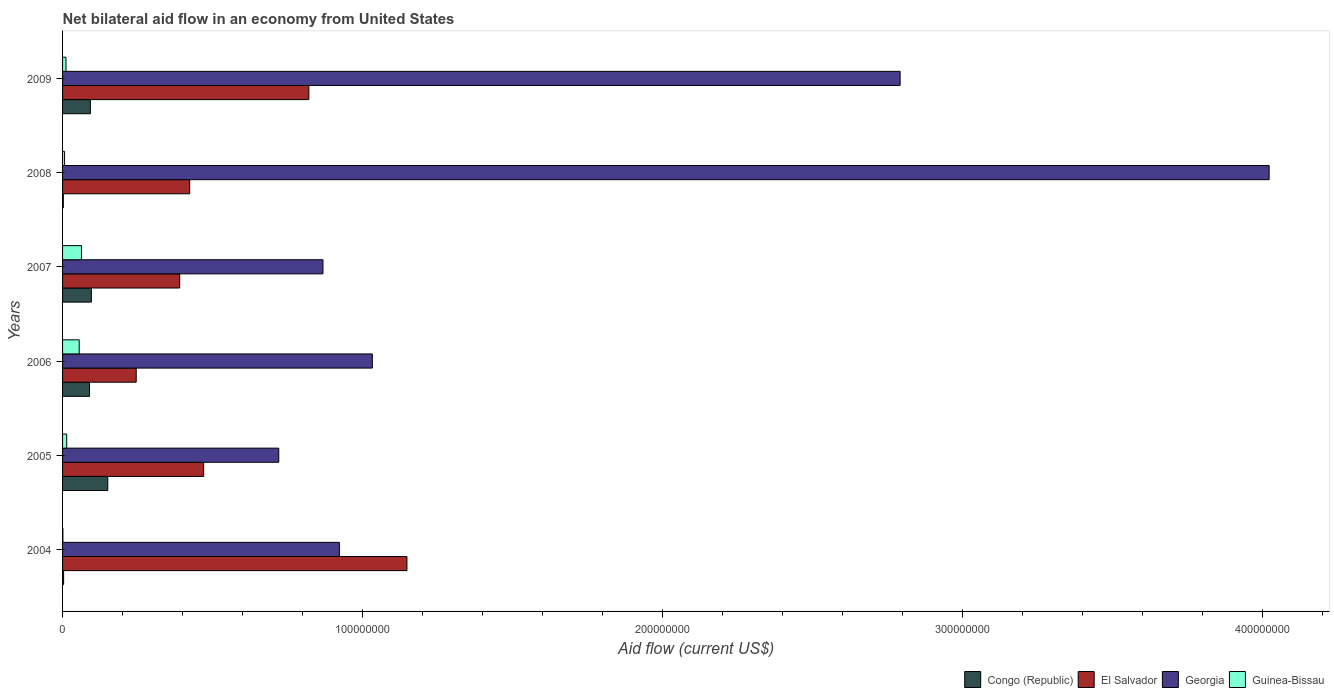How many groups of bars are there?
Ensure brevity in your answer.  6. Are the number of bars per tick equal to the number of legend labels?
Keep it short and to the point. Yes. Are the number of bars on each tick of the Y-axis equal?
Your response must be concise. Yes. How many bars are there on the 6th tick from the top?
Offer a very short reply. 4. How many bars are there on the 3rd tick from the bottom?
Give a very brief answer. 4. What is the net bilateral aid flow in El Salvador in 2005?
Offer a terse response. 4.70e+07. Across all years, what is the maximum net bilateral aid flow in Georgia?
Offer a very short reply. 4.02e+08. Across all years, what is the minimum net bilateral aid flow in Georgia?
Provide a short and direct response. 7.20e+07. In which year was the net bilateral aid flow in El Salvador maximum?
Make the answer very short. 2004. In which year was the net bilateral aid flow in Congo (Republic) minimum?
Offer a very short reply. 2008. What is the total net bilateral aid flow in Guinea-Bissau in the graph?
Offer a very short reply. 1.51e+07. What is the difference between the net bilateral aid flow in Guinea-Bissau in 2004 and that in 2009?
Provide a short and direct response. -1.03e+06. What is the difference between the net bilateral aid flow in Guinea-Bissau in 2006 and the net bilateral aid flow in Congo (Republic) in 2007?
Ensure brevity in your answer.  -4.06e+06. What is the average net bilateral aid flow in Congo (Republic) per year?
Offer a terse response. 7.26e+06. In the year 2009, what is the difference between the net bilateral aid flow in Guinea-Bissau and net bilateral aid flow in Congo (Republic)?
Give a very brief answer. -8.13e+06. In how many years, is the net bilateral aid flow in El Salvador greater than 80000000 US$?
Provide a succinct answer. 2. What is the ratio of the net bilateral aid flow in Georgia in 2005 to that in 2006?
Offer a very short reply. 0.7. What is the difference between the highest and the second highest net bilateral aid flow in Congo (Republic)?
Provide a short and direct response. 5.47e+06. What is the difference between the highest and the lowest net bilateral aid flow in Congo (Republic)?
Your answer should be very brief. 1.48e+07. In how many years, is the net bilateral aid flow in Congo (Republic) greater than the average net bilateral aid flow in Congo (Republic) taken over all years?
Offer a terse response. 4. What does the 1st bar from the top in 2006 represents?
Give a very brief answer. Guinea-Bissau. What does the 2nd bar from the bottom in 2006 represents?
Make the answer very short. El Salvador. Is it the case that in every year, the sum of the net bilateral aid flow in El Salvador and net bilateral aid flow in Georgia is greater than the net bilateral aid flow in Congo (Republic)?
Give a very brief answer. Yes. How many bars are there?
Offer a very short reply. 24. What is the difference between two consecutive major ticks on the X-axis?
Offer a very short reply. 1.00e+08. Where does the legend appear in the graph?
Your response must be concise. Bottom right. What is the title of the graph?
Offer a terse response. Net bilateral aid flow in an economy from United States. What is the Aid flow (current US$) of Congo (Republic) in 2004?
Provide a succinct answer. 3.50e+05. What is the Aid flow (current US$) in El Salvador in 2004?
Your answer should be compact. 1.15e+08. What is the Aid flow (current US$) of Georgia in 2004?
Make the answer very short. 9.23e+07. What is the Aid flow (current US$) of Guinea-Bissau in 2004?
Your answer should be very brief. 1.10e+05. What is the Aid flow (current US$) of Congo (Republic) in 2005?
Your response must be concise. 1.51e+07. What is the Aid flow (current US$) in El Salvador in 2005?
Offer a terse response. 4.70e+07. What is the Aid flow (current US$) of Georgia in 2005?
Offer a terse response. 7.20e+07. What is the Aid flow (current US$) in Guinea-Bissau in 2005?
Your answer should be compact. 1.38e+06. What is the Aid flow (current US$) in Congo (Republic) in 2006?
Offer a very short reply. 8.98e+06. What is the Aid flow (current US$) in El Salvador in 2006?
Your answer should be very brief. 2.45e+07. What is the Aid flow (current US$) of Georgia in 2006?
Ensure brevity in your answer.  1.03e+08. What is the Aid flow (current US$) in Guinea-Bissau in 2006?
Provide a succinct answer. 5.54e+06. What is the Aid flow (current US$) of Congo (Republic) in 2007?
Provide a short and direct response. 9.60e+06. What is the Aid flow (current US$) in El Salvador in 2007?
Your answer should be very brief. 3.90e+07. What is the Aid flow (current US$) of Georgia in 2007?
Your response must be concise. 8.68e+07. What is the Aid flow (current US$) of Guinea-Bissau in 2007?
Provide a succinct answer. 6.30e+06. What is the Aid flow (current US$) in El Salvador in 2008?
Provide a succinct answer. 4.24e+07. What is the Aid flow (current US$) in Georgia in 2008?
Offer a very short reply. 4.02e+08. What is the Aid flow (current US$) of Guinea-Bissau in 2008?
Provide a succinct answer. 6.70e+05. What is the Aid flow (current US$) in Congo (Republic) in 2009?
Offer a terse response. 9.27e+06. What is the Aid flow (current US$) in El Salvador in 2009?
Offer a very short reply. 8.21e+07. What is the Aid flow (current US$) of Georgia in 2009?
Provide a succinct answer. 2.79e+08. What is the Aid flow (current US$) of Guinea-Bissau in 2009?
Your response must be concise. 1.14e+06. Across all years, what is the maximum Aid flow (current US$) of Congo (Republic)?
Ensure brevity in your answer.  1.51e+07. Across all years, what is the maximum Aid flow (current US$) in El Salvador?
Keep it short and to the point. 1.15e+08. Across all years, what is the maximum Aid flow (current US$) in Georgia?
Provide a short and direct response. 4.02e+08. Across all years, what is the maximum Aid flow (current US$) of Guinea-Bissau?
Keep it short and to the point. 6.30e+06. Across all years, what is the minimum Aid flow (current US$) of El Salvador?
Provide a short and direct response. 2.45e+07. Across all years, what is the minimum Aid flow (current US$) of Georgia?
Make the answer very short. 7.20e+07. Across all years, what is the minimum Aid flow (current US$) in Guinea-Bissau?
Provide a succinct answer. 1.10e+05. What is the total Aid flow (current US$) of Congo (Republic) in the graph?
Make the answer very short. 4.35e+07. What is the total Aid flow (current US$) of El Salvador in the graph?
Provide a short and direct response. 3.50e+08. What is the total Aid flow (current US$) in Georgia in the graph?
Your answer should be compact. 1.04e+09. What is the total Aid flow (current US$) in Guinea-Bissau in the graph?
Keep it short and to the point. 1.51e+07. What is the difference between the Aid flow (current US$) in Congo (Republic) in 2004 and that in 2005?
Make the answer very short. -1.47e+07. What is the difference between the Aid flow (current US$) in El Salvador in 2004 and that in 2005?
Provide a succinct answer. 6.77e+07. What is the difference between the Aid flow (current US$) of Georgia in 2004 and that in 2005?
Your answer should be very brief. 2.02e+07. What is the difference between the Aid flow (current US$) in Guinea-Bissau in 2004 and that in 2005?
Ensure brevity in your answer.  -1.27e+06. What is the difference between the Aid flow (current US$) of Congo (Republic) in 2004 and that in 2006?
Your answer should be very brief. -8.63e+06. What is the difference between the Aid flow (current US$) in El Salvador in 2004 and that in 2006?
Ensure brevity in your answer.  9.02e+07. What is the difference between the Aid flow (current US$) of Georgia in 2004 and that in 2006?
Ensure brevity in your answer.  -1.10e+07. What is the difference between the Aid flow (current US$) of Guinea-Bissau in 2004 and that in 2006?
Give a very brief answer. -5.43e+06. What is the difference between the Aid flow (current US$) of Congo (Republic) in 2004 and that in 2007?
Give a very brief answer. -9.25e+06. What is the difference between the Aid flow (current US$) of El Salvador in 2004 and that in 2007?
Your response must be concise. 7.57e+07. What is the difference between the Aid flow (current US$) of Georgia in 2004 and that in 2007?
Make the answer very short. 5.48e+06. What is the difference between the Aid flow (current US$) of Guinea-Bissau in 2004 and that in 2007?
Give a very brief answer. -6.19e+06. What is the difference between the Aid flow (current US$) of Congo (Republic) in 2004 and that in 2008?
Ensure brevity in your answer.  9.00e+04. What is the difference between the Aid flow (current US$) of El Salvador in 2004 and that in 2008?
Make the answer very short. 7.24e+07. What is the difference between the Aid flow (current US$) in Georgia in 2004 and that in 2008?
Offer a very short reply. -3.10e+08. What is the difference between the Aid flow (current US$) in Guinea-Bissau in 2004 and that in 2008?
Provide a short and direct response. -5.60e+05. What is the difference between the Aid flow (current US$) in Congo (Republic) in 2004 and that in 2009?
Provide a short and direct response. -8.92e+06. What is the difference between the Aid flow (current US$) in El Salvador in 2004 and that in 2009?
Your answer should be very brief. 3.27e+07. What is the difference between the Aid flow (current US$) of Georgia in 2004 and that in 2009?
Make the answer very short. -1.87e+08. What is the difference between the Aid flow (current US$) in Guinea-Bissau in 2004 and that in 2009?
Make the answer very short. -1.03e+06. What is the difference between the Aid flow (current US$) in Congo (Republic) in 2005 and that in 2006?
Keep it short and to the point. 6.09e+06. What is the difference between the Aid flow (current US$) in El Salvador in 2005 and that in 2006?
Keep it short and to the point. 2.25e+07. What is the difference between the Aid flow (current US$) in Georgia in 2005 and that in 2006?
Make the answer very short. -3.12e+07. What is the difference between the Aid flow (current US$) in Guinea-Bissau in 2005 and that in 2006?
Offer a very short reply. -4.16e+06. What is the difference between the Aid flow (current US$) in Congo (Republic) in 2005 and that in 2007?
Offer a very short reply. 5.47e+06. What is the difference between the Aid flow (current US$) of El Salvador in 2005 and that in 2007?
Your response must be concise. 7.98e+06. What is the difference between the Aid flow (current US$) of Georgia in 2005 and that in 2007?
Your response must be concise. -1.47e+07. What is the difference between the Aid flow (current US$) of Guinea-Bissau in 2005 and that in 2007?
Provide a short and direct response. -4.92e+06. What is the difference between the Aid flow (current US$) in Congo (Republic) in 2005 and that in 2008?
Your answer should be compact. 1.48e+07. What is the difference between the Aid flow (current US$) of El Salvador in 2005 and that in 2008?
Keep it short and to the point. 4.65e+06. What is the difference between the Aid flow (current US$) of Georgia in 2005 and that in 2008?
Your answer should be compact. -3.30e+08. What is the difference between the Aid flow (current US$) in Guinea-Bissau in 2005 and that in 2008?
Give a very brief answer. 7.10e+05. What is the difference between the Aid flow (current US$) of Congo (Republic) in 2005 and that in 2009?
Make the answer very short. 5.80e+06. What is the difference between the Aid flow (current US$) of El Salvador in 2005 and that in 2009?
Provide a short and direct response. -3.51e+07. What is the difference between the Aid flow (current US$) in Georgia in 2005 and that in 2009?
Ensure brevity in your answer.  -2.07e+08. What is the difference between the Aid flow (current US$) of Guinea-Bissau in 2005 and that in 2009?
Your answer should be compact. 2.40e+05. What is the difference between the Aid flow (current US$) of Congo (Republic) in 2006 and that in 2007?
Make the answer very short. -6.20e+05. What is the difference between the Aid flow (current US$) in El Salvador in 2006 and that in 2007?
Provide a succinct answer. -1.45e+07. What is the difference between the Aid flow (current US$) in Georgia in 2006 and that in 2007?
Give a very brief answer. 1.65e+07. What is the difference between the Aid flow (current US$) of Guinea-Bissau in 2006 and that in 2007?
Provide a short and direct response. -7.60e+05. What is the difference between the Aid flow (current US$) of Congo (Republic) in 2006 and that in 2008?
Make the answer very short. 8.72e+06. What is the difference between the Aid flow (current US$) in El Salvador in 2006 and that in 2008?
Provide a short and direct response. -1.78e+07. What is the difference between the Aid flow (current US$) of Georgia in 2006 and that in 2008?
Give a very brief answer. -2.99e+08. What is the difference between the Aid flow (current US$) of Guinea-Bissau in 2006 and that in 2008?
Offer a very short reply. 4.87e+06. What is the difference between the Aid flow (current US$) of El Salvador in 2006 and that in 2009?
Offer a terse response. -5.75e+07. What is the difference between the Aid flow (current US$) of Georgia in 2006 and that in 2009?
Your answer should be compact. -1.76e+08. What is the difference between the Aid flow (current US$) of Guinea-Bissau in 2006 and that in 2009?
Give a very brief answer. 4.40e+06. What is the difference between the Aid flow (current US$) in Congo (Republic) in 2007 and that in 2008?
Keep it short and to the point. 9.34e+06. What is the difference between the Aid flow (current US$) of El Salvador in 2007 and that in 2008?
Offer a very short reply. -3.33e+06. What is the difference between the Aid flow (current US$) of Georgia in 2007 and that in 2008?
Offer a very short reply. -3.15e+08. What is the difference between the Aid flow (current US$) of Guinea-Bissau in 2007 and that in 2008?
Provide a succinct answer. 5.63e+06. What is the difference between the Aid flow (current US$) of El Salvador in 2007 and that in 2009?
Ensure brevity in your answer.  -4.30e+07. What is the difference between the Aid flow (current US$) in Georgia in 2007 and that in 2009?
Make the answer very short. -1.92e+08. What is the difference between the Aid flow (current US$) of Guinea-Bissau in 2007 and that in 2009?
Provide a succinct answer. 5.16e+06. What is the difference between the Aid flow (current US$) of Congo (Republic) in 2008 and that in 2009?
Your answer should be very brief. -9.01e+06. What is the difference between the Aid flow (current US$) in El Salvador in 2008 and that in 2009?
Ensure brevity in your answer.  -3.97e+07. What is the difference between the Aid flow (current US$) in Georgia in 2008 and that in 2009?
Provide a succinct answer. 1.23e+08. What is the difference between the Aid flow (current US$) in Guinea-Bissau in 2008 and that in 2009?
Your response must be concise. -4.70e+05. What is the difference between the Aid flow (current US$) in Congo (Republic) in 2004 and the Aid flow (current US$) in El Salvador in 2005?
Your answer should be very brief. -4.67e+07. What is the difference between the Aid flow (current US$) in Congo (Republic) in 2004 and the Aid flow (current US$) in Georgia in 2005?
Offer a terse response. -7.17e+07. What is the difference between the Aid flow (current US$) in Congo (Republic) in 2004 and the Aid flow (current US$) in Guinea-Bissau in 2005?
Provide a succinct answer. -1.03e+06. What is the difference between the Aid flow (current US$) in El Salvador in 2004 and the Aid flow (current US$) in Georgia in 2005?
Your response must be concise. 4.27e+07. What is the difference between the Aid flow (current US$) in El Salvador in 2004 and the Aid flow (current US$) in Guinea-Bissau in 2005?
Your response must be concise. 1.13e+08. What is the difference between the Aid flow (current US$) in Georgia in 2004 and the Aid flow (current US$) in Guinea-Bissau in 2005?
Your answer should be very brief. 9.09e+07. What is the difference between the Aid flow (current US$) of Congo (Republic) in 2004 and the Aid flow (current US$) of El Salvador in 2006?
Offer a very short reply. -2.42e+07. What is the difference between the Aid flow (current US$) in Congo (Republic) in 2004 and the Aid flow (current US$) in Georgia in 2006?
Provide a short and direct response. -1.03e+08. What is the difference between the Aid flow (current US$) of Congo (Republic) in 2004 and the Aid flow (current US$) of Guinea-Bissau in 2006?
Your answer should be very brief. -5.19e+06. What is the difference between the Aid flow (current US$) of El Salvador in 2004 and the Aid flow (current US$) of Georgia in 2006?
Offer a very short reply. 1.15e+07. What is the difference between the Aid flow (current US$) of El Salvador in 2004 and the Aid flow (current US$) of Guinea-Bissau in 2006?
Provide a succinct answer. 1.09e+08. What is the difference between the Aid flow (current US$) in Georgia in 2004 and the Aid flow (current US$) in Guinea-Bissau in 2006?
Offer a very short reply. 8.67e+07. What is the difference between the Aid flow (current US$) of Congo (Republic) in 2004 and the Aid flow (current US$) of El Salvador in 2007?
Provide a short and direct response. -3.87e+07. What is the difference between the Aid flow (current US$) of Congo (Republic) in 2004 and the Aid flow (current US$) of Georgia in 2007?
Your answer should be compact. -8.64e+07. What is the difference between the Aid flow (current US$) in Congo (Republic) in 2004 and the Aid flow (current US$) in Guinea-Bissau in 2007?
Your response must be concise. -5.95e+06. What is the difference between the Aid flow (current US$) of El Salvador in 2004 and the Aid flow (current US$) of Georgia in 2007?
Make the answer very short. 2.80e+07. What is the difference between the Aid flow (current US$) in El Salvador in 2004 and the Aid flow (current US$) in Guinea-Bissau in 2007?
Offer a very short reply. 1.08e+08. What is the difference between the Aid flow (current US$) in Georgia in 2004 and the Aid flow (current US$) in Guinea-Bissau in 2007?
Offer a very short reply. 8.60e+07. What is the difference between the Aid flow (current US$) of Congo (Republic) in 2004 and the Aid flow (current US$) of El Salvador in 2008?
Your answer should be very brief. -4.20e+07. What is the difference between the Aid flow (current US$) in Congo (Republic) in 2004 and the Aid flow (current US$) in Georgia in 2008?
Provide a succinct answer. -4.02e+08. What is the difference between the Aid flow (current US$) in Congo (Republic) in 2004 and the Aid flow (current US$) in Guinea-Bissau in 2008?
Your answer should be very brief. -3.20e+05. What is the difference between the Aid flow (current US$) in El Salvador in 2004 and the Aid flow (current US$) in Georgia in 2008?
Provide a succinct answer. -2.87e+08. What is the difference between the Aid flow (current US$) of El Salvador in 2004 and the Aid flow (current US$) of Guinea-Bissau in 2008?
Offer a very short reply. 1.14e+08. What is the difference between the Aid flow (current US$) in Georgia in 2004 and the Aid flow (current US$) in Guinea-Bissau in 2008?
Provide a succinct answer. 9.16e+07. What is the difference between the Aid flow (current US$) in Congo (Republic) in 2004 and the Aid flow (current US$) in El Salvador in 2009?
Your answer should be very brief. -8.17e+07. What is the difference between the Aid flow (current US$) in Congo (Republic) in 2004 and the Aid flow (current US$) in Georgia in 2009?
Keep it short and to the point. -2.79e+08. What is the difference between the Aid flow (current US$) in Congo (Republic) in 2004 and the Aid flow (current US$) in Guinea-Bissau in 2009?
Offer a very short reply. -7.90e+05. What is the difference between the Aid flow (current US$) in El Salvador in 2004 and the Aid flow (current US$) in Georgia in 2009?
Keep it short and to the point. -1.64e+08. What is the difference between the Aid flow (current US$) in El Salvador in 2004 and the Aid flow (current US$) in Guinea-Bissau in 2009?
Make the answer very short. 1.14e+08. What is the difference between the Aid flow (current US$) in Georgia in 2004 and the Aid flow (current US$) in Guinea-Bissau in 2009?
Provide a short and direct response. 9.11e+07. What is the difference between the Aid flow (current US$) of Congo (Republic) in 2005 and the Aid flow (current US$) of El Salvador in 2006?
Offer a terse response. -9.47e+06. What is the difference between the Aid flow (current US$) in Congo (Republic) in 2005 and the Aid flow (current US$) in Georgia in 2006?
Provide a succinct answer. -8.82e+07. What is the difference between the Aid flow (current US$) of Congo (Republic) in 2005 and the Aid flow (current US$) of Guinea-Bissau in 2006?
Keep it short and to the point. 9.53e+06. What is the difference between the Aid flow (current US$) of El Salvador in 2005 and the Aid flow (current US$) of Georgia in 2006?
Provide a succinct answer. -5.62e+07. What is the difference between the Aid flow (current US$) in El Salvador in 2005 and the Aid flow (current US$) in Guinea-Bissau in 2006?
Offer a terse response. 4.15e+07. What is the difference between the Aid flow (current US$) in Georgia in 2005 and the Aid flow (current US$) in Guinea-Bissau in 2006?
Your response must be concise. 6.65e+07. What is the difference between the Aid flow (current US$) in Congo (Republic) in 2005 and the Aid flow (current US$) in El Salvador in 2007?
Offer a very short reply. -2.40e+07. What is the difference between the Aid flow (current US$) in Congo (Republic) in 2005 and the Aid flow (current US$) in Georgia in 2007?
Make the answer very short. -7.17e+07. What is the difference between the Aid flow (current US$) in Congo (Republic) in 2005 and the Aid flow (current US$) in Guinea-Bissau in 2007?
Make the answer very short. 8.77e+06. What is the difference between the Aid flow (current US$) of El Salvador in 2005 and the Aid flow (current US$) of Georgia in 2007?
Your answer should be compact. -3.98e+07. What is the difference between the Aid flow (current US$) in El Salvador in 2005 and the Aid flow (current US$) in Guinea-Bissau in 2007?
Your answer should be very brief. 4.07e+07. What is the difference between the Aid flow (current US$) of Georgia in 2005 and the Aid flow (current US$) of Guinea-Bissau in 2007?
Make the answer very short. 6.58e+07. What is the difference between the Aid flow (current US$) of Congo (Republic) in 2005 and the Aid flow (current US$) of El Salvador in 2008?
Ensure brevity in your answer.  -2.73e+07. What is the difference between the Aid flow (current US$) of Congo (Republic) in 2005 and the Aid flow (current US$) of Georgia in 2008?
Keep it short and to the point. -3.87e+08. What is the difference between the Aid flow (current US$) in Congo (Republic) in 2005 and the Aid flow (current US$) in Guinea-Bissau in 2008?
Provide a short and direct response. 1.44e+07. What is the difference between the Aid flow (current US$) in El Salvador in 2005 and the Aid flow (current US$) in Georgia in 2008?
Your answer should be compact. -3.55e+08. What is the difference between the Aid flow (current US$) in El Salvador in 2005 and the Aid flow (current US$) in Guinea-Bissau in 2008?
Your answer should be very brief. 4.64e+07. What is the difference between the Aid flow (current US$) of Georgia in 2005 and the Aid flow (current US$) of Guinea-Bissau in 2008?
Ensure brevity in your answer.  7.14e+07. What is the difference between the Aid flow (current US$) in Congo (Republic) in 2005 and the Aid flow (current US$) in El Salvador in 2009?
Your answer should be very brief. -6.70e+07. What is the difference between the Aid flow (current US$) in Congo (Republic) in 2005 and the Aid flow (current US$) in Georgia in 2009?
Make the answer very short. -2.64e+08. What is the difference between the Aid flow (current US$) of Congo (Republic) in 2005 and the Aid flow (current US$) of Guinea-Bissau in 2009?
Offer a terse response. 1.39e+07. What is the difference between the Aid flow (current US$) in El Salvador in 2005 and the Aid flow (current US$) in Georgia in 2009?
Your response must be concise. -2.32e+08. What is the difference between the Aid flow (current US$) in El Salvador in 2005 and the Aid flow (current US$) in Guinea-Bissau in 2009?
Offer a very short reply. 4.59e+07. What is the difference between the Aid flow (current US$) in Georgia in 2005 and the Aid flow (current US$) in Guinea-Bissau in 2009?
Provide a short and direct response. 7.09e+07. What is the difference between the Aid flow (current US$) of Congo (Republic) in 2006 and the Aid flow (current US$) of El Salvador in 2007?
Your answer should be compact. -3.01e+07. What is the difference between the Aid flow (current US$) in Congo (Republic) in 2006 and the Aid flow (current US$) in Georgia in 2007?
Ensure brevity in your answer.  -7.78e+07. What is the difference between the Aid flow (current US$) in Congo (Republic) in 2006 and the Aid flow (current US$) in Guinea-Bissau in 2007?
Ensure brevity in your answer.  2.68e+06. What is the difference between the Aid flow (current US$) of El Salvador in 2006 and the Aid flow (current US$) of Georgia in 2007?
Provide a succinct answer. -6.22e+07. What is the difference between the Aid flow (current US$) in El Salvador in 2006 and the Aid flow (current US$) in Guinea-Bissau in 2007?
Your response must be concise. 1.82e+07. What is the difference between the Aid flow (current US$) of Georgia in 2006 and the Aid flow (current US$) of Guinea-Bissau in 2007?
Your response must be concise. 9.69e+07. What is the difference between the Aid flow (current US$) of Congo (Republic) in 2006 and the Aid flow (current US$) of El Salvador in 2008?
Offer a very short reply. -3.34e+07. What is the difference between the Aid flow (current US$) in Congo (Republic) in 2006 and the Aid flow (current US$) in Georgia in 2008?
Your answer should be very brief. -3.93e+08. What is the difference between the Aid flow (current US$) of Congo (Republic) in 2006 and the Aid flow (current US$) of Guinea-Bissau in 2008?
Your answer should be compact. 8.31e+06. What is the difference between the Aid flow (current US$) in El Salvador in 2006 and the Aid flow (current US$) in Georgia in 2008?
Make the answer very short. -3.78e+08. What is the difference between the Aid flow (current US$) in El Salvador in 2006 and the Aid flow (current US$) in Guinea-Bissau in 2008?
Make the answer very short. 2.39e+07. What is the difference between the Aid flow (current US$) in Georgia in 2006 and the Aid flow (current US$) in Guinea-Bissau in 2008?
Your response must be concise. 1.03e+08. What is the difference between the Aid flow (current US$) in Congo (Republic) in 2006 and the Aid flow (current US$) in El Salvador in 2009?
Ensure brevity in your answer.  -7.31e+07. What is the difference between the Aid flow (current US$) in Congo (Republic) in 2006 and the Aid flow (current US$) in Georgia in 2009?
Provide a succinct answer. -2.70e+08. What is the difference between the Aid flow (current US$) in Congo (Republic) in 2006 and the Aid flow (current US$) in Guinea-Bissau in 2009?
Your answer should be compact. 7.84e+06. What is the difference between the Aid flow (current US$) in El Salvador in 2006 and the Aid flow (current US$) in Georgia in 2009?
Give a very brief answer. -2.55e+08. What is the difference between the Aid flow (current US$) in El Salvador in 2006 and the Aid flow (current US$) in Guinea-Bissau in 2009?
Offer a terse response. 2.34e+07. What is the difference between the Aid flow (current US$) of Georgia in 2006 and the Aid flow (current US$) of Guinea-Bissau in 2009?
Ensure brevity in your answer.  1.02e+08. What is the difference between the Aid flow (current US$) in Congo (Republic) in 2007 and the Aid flow (current US$) in El Salvador in 2008?
Your answer should be compact. -3.28e+07. What is the difference between the Aid flow (current US$) in Congo (Republic) in 2007 and the Aid flow (current US$) in Georgia in 2008?
Your answer should be very brief. -3.92e+08. What is the difference between the Aid flow (current US$) in Congo (Republic) in 2007 and the Aid flow (current US$) in Guinea-Bissau in 2008?
Offer a very short reply. 8.93e+06. What is the difference between the Aid flow (current US$) of El Salvador in 2007 and the Aid flow (current US$) of Georgia in 2008?
Your answer should be very brief. -3.63e+08. What is the difference between the Aid flow (current US$) in El Salvador in 2007 and the Aid flow (current US$) in Guinea-Bissau in 2008?
Keep it short and to the point. 3.84e+07. What is the difference between the Aid flow (current US$) in Georgia in 2007 and the Aid flow (current US$) in Guinea-Bissau in 2008?
Offer a very short reply. 8.61e+07. What is the difference between the Aid flow (current US$) in Congo (Republic) in 2007 and the Aid flow (current US$) in El Salvador in 2009?
Provide a succinct answer. -7.25e+07. What is the difference between the Aid flow (current US$) in Congo (Republic) in 2007 and the Aid flow (current US$) in Georgia in 2009?
Make the answer very short. -2.70e+08. What is the difference between the Aid flow (current US$) in Congo (Republic) in 2007 and the Aid flow (current US$) in Guinea-Bissau in 2009?
Your answer should be very brief. 8.46e+06. What is the difference between the Aid flow (current US$) of El Salvador in 2007 and the Aid flow (current US$) of Georgia in 2009?
Your answer should be compact. -2.40e+08. What is the difference between the Aid flow (current US$) in El Salvador in 2007 and the Aid flow (current US$) in Guinea-Bissau in 2009?
Your answer should be very brief. 3.79e+07. What is the difference between the Aid flow (current US$) of Georgia in 2007 and the Aid flow (current US$) of Guinea-Bissau in 2009?
Provide a succinct answer. 8.56e+07. What is the difference between the Aid flow (current US$) in Congo (Republic) in 2008 and the Aid flow (current US$) in El Salvador in 2009?
Make the answer very short. -8.18e+07. What is the difference between the Aid flow (current US$) in Congo (Republic) in 2008 and the Aid flow (current US$) in Georgia in 2009?
Ensure brevity in your answer.  -2.79e+08. What is the difference between the Aid flow (current US$) in Congo (Republic) in 2008 and the Aid flow (current US$) in Guinea-Bissau in 2009?
Keep it short and to the point. -8.80e+05. What is the difference between the Aid flow (current US$) of El Salvador in 2008 and the Aid flow (current US$) of Georgia in 2009?
Provide a short and direct response. -2.37e+08. What is the difference between the Aid flow (current US$) in El Salvador in 2008 and the Aid flow (current US$) in Guinea-Bissau in 2009?
Your answer should be very brief. 4.12e+07. What is the difference between the Aid flow (current US$) in Georgia in 2008 and the Aid flow (current US$) in Guinea-Bissau in 2009?
Offer a terse response. 4.01e+08. What is the average Aid flow (current US$) in Congo (Republic) per year?
Your answer should be very brief. 7.26e+06. What is the average Aid flow (current US$) in El Salvador per year?
Your response must be concise. 5.83e+07. What is the average Aid flow (current US$) of Georgia per year?
Ensure brevity in your answer.  1.73e+08. What is the average Aid flow (current US$) of Guinea-Bissau per year?
Keep it short and to the point. 2.52e+06. In the year 2004, what is the difference between the Aid flow (current US$) in Congo (Republic) and Aid flow (current US$) in El Salvador?
Offer a terse response. -1.14e+08. In the year 2004, what is the difference between the Aid flow (current US$) in Congo (Republic) and Aid flow (current US$) in Georgia?
Provide a succinct answer. -9.19e+07. In the year 2004, what is the difference between the Aid flow (current US$) in El Salvador and Aid flow (current US$) in Georgia?
Offer a terse response. 2.25e+07. In the year 2004, what is the difference between the Aid flow (current US$) in El Salvador and Aid flow (current US$) in Guinea-Bissau?
Offer a very short reply. 1.15e+08. In the year 2004, what is the difference between the Aid flow (current US$) of Georgia and Aid flow (current US$) of Guinea-Bissau?
Offer a very short reply. 9.22e+07. In the year 2005, what is the difference between the Aid flow (current US$) in Congo (Republic) and Aid flow (current US$) in El Salvador?
Provide a short and direct response. -3.20e+07. In the year 2005, what is the difference between the Aid flow (current US$) in Congo (Republic) and Aid flow (current US$) in Georgia?
Your response must be concise. -5.70e+07. In the year 2005, what is the difference between the Aid flow (current US$) of Congo (Republic) and Aid flow (current US$) of Guinea-Bissau?
Provide a short and direct response. 1.37e+07. In the year 2005, what is the difference between the Aid flow (current US$) of El Salvador and Aid flow (current US$) of Georgia?
Make the answer very short. -2.50e+07. In the year 2005, what is the difference between the Aid flow (current US$) of El Salvador and Aid flow (current US$) of Guinea-Bissau?
Ensure brevity in your answer.  4.56e+07. In the year 2005, what is the difference between the Aid flow (current US$) in Georgia and Aid flow (current US$) in Guinea-Bissau?
Offer a terse response. 7.07e+07. In the year 2006, what is the difference between the Aid flow (current US$) of Congo (Republic) and Aid flow (current US$) of El Salvador?
Provide a short and direct response. -1.56e+07. In the year 2006, what is the difference between the Aid flow (current US$) in Congo (Republic) and Aid flow (current US$) in Georgia?
Your response must be concise. -9.43e+07. In the year 2006, what is the difference between the Aid flow (current US$) in Congo (Republic) and Aid flow (current US$) in Guinea-Bissau?
Keep it short and to the point. 3.44e+06. In the year 2006, what is the difference between the Aid flow (current US$) of El Salvador and Aid flow (current US$) of Georgia?
Offer a very short reply. -7.87e+07. In the year 2006, what is the difference between the Aid flow (current US$) of El Salvador and Aid flow (current US$) of Guinea-Bissau?
Provide a short and direct response. 1.90e+07. In the year 2006, what is the difference between the Aid flow (current US$) of Georgia and Aid flow (current US$) of Guinea-Bissau?
Your answer should be compact. 9.77e+07. In the year 2007, what is the difference between the Aid flow (current US$) of Congo (Republic) and Aid flow (current US$) of El Salvador?
Make the answer very short. -2.94e+07. In the year 2007, what is the difference between the Aid flow (current US$) in Congo (Republic) and Aid flow (current US$) in Georgia?
Make the answer very short. -7.72e+07. In the year 2007, what is the difference between the Aid flow (current US$) of Congo (Republic) and Aid flow (current US$) of Guinea-Bissau?
Provide a short and direct response. 3.30e+06. In the year 2007, what is the difference between the Aid flow (current US$) of El Salvador and Aid flow (current US$) of Georgia?
Your answer should be compact. -4.77e+07. In the year 2007, what is the difference between the Aid flow (current US$) in El Salvador and Aid flow (current US$) in Guinea-Bissau?
Offer a terse response. 3.27e+07. In the year 2007, what is the difference between the Aid flow (current US$) of Georgia and Aid flow (current US$) of Guinea-Bissau?
Keep it short and to the point. 8.05e+07. In the year 2008, what is the difference between the Aid flow (current US$) in Congo (Republic) and Aid flow (current US$) in El Salvador?
Keep it short and to the point. -4.21e+07. In the year 2008, what is the difference between the Aid flow (current US$) of Congo (Republic) and Aid flow (current US$) of Georgia?
Keep it short and to the point. -4.02e+08. In the year 2008, what is the difference between the Aid flow (current US$) in Congo (Republic) and Aid flow (current US$) in Guinea-Bissau?
Your answer should be very brief. -4.10e+05. In the year 2008, what is the difference between the Aid flow (current US$) of El Salvador and Aid flow (current US$) of Georgia?
Offer a terse response. -3.60e+08. In the year 2008, what is the difference between the Aid flow (current US$) in El Salvador and Aid flow (current US$) in Guinea-Bissau?
Provide a short and direct response. 4.17e+07. In the year 2008, what is the difference between the Aid flow (current US$) of Georgia and Aid flow (current US$) of Guinea-Bissau?
Provide a succinct answer. 4.01e+08. In the year 2009, what is the difference between the Aid flow (current US$) of Congo (Republic) and Aid flow (current US$) of El Salvador?
Your answer should be compact. -7.28e+07. In the year 2009, what is the difference between the Aid flow (current US$) of Congo (Republic) and Aid flow (current US$) of Georgia?
Ensure brevity in your answer.  -2.70e+08. In the year 2009, what is the difference between the Aid flow (current US$) in Congo (Republic) and Aid flow (current US$) in Guinea-Bissau?
Give a very brief answer. 8.13e+06. In the year 2009, what is the difference between the Aid flow (current US$) in El Salvador and Aid flow (current US$) in Georgia?
Your answer should be compact. -1.97e+08. In the year 2009, what is the difference between the Aid flow (current US$) of El Salvador and Aid flow (current US$) of Guinea-Bissau?
Make the answer very short. 8.09e+07. In the year 2009, what is the difference between the Aid flow (current US$) of Georgia and Aid flow (current US$) of Guinea-Bissau?
Your answer should be very brief. 2.78e+08. What is the ratio of the Aid flow (current US$) in Congo (Republic) in 2004 to that in 2005?
Provide a short and direct response. 0.02. What is the ratio of the Aid flow (current US$) of El Salvador in 2004 to that in 2005?
Provide a short and direct response. 2.44. What is the ratio of the Aid flow (current US$) of Georgia in 2004 to that in 2005?
Your answer should be very brief. 1.28. What is the ratio of the Aid flow (current US$) of Guinea-Bissau in 2004 to that in 2005?
Make the answer very short. 0.08. What is the ratio of the Aid flow (current US$) in Congo (Republic) in 2004 to that in 2006?
Make the answer very short. 0.04. What is the ratio of the Aid flow (current US$) of El Salvador in 2004 to that in 2006?
Ensure brevity in your answer.  4.68. What is the ratio of the Aid flow (current US$) in Georgia in 2004 to that in 2006?
Your answer should be compact. 0.89. What is the ratio of the Aid flow (current US$) of Guinea-Bissau in 2004 to that in 2006?
Provide a succinct answer. 0.02. What is the ratio of the Aid flow (current US$) of Congo (Republic) in 2004 to that in 2007?
Offer a very short reply. 0.04. What is the ratio of the Aid flow (current US$) of El Salvador in 2004 to that in 2007?
Provide a succinct answer. 2.94. What is the ratio of the Aid flow (current US$) of Georgia in 2004 to that in 2007?
Offer a very short reply. 1.06. What is the ratio of the Aid flow (current US$) of Guinea-Bissau in 2004 to that in 2007?
Provide a succinct answer. 0.02. What is the ratio of the Aid flow (current US$) of Congo (Republic) in 2004 to that in 2008?
Provide a short and direct response. 1.35. What is the ratio of the Aid flow (current US$) in El Salvador in 2004 to that in 2008?
Give a very brief answer. 2.71. What is the ratio of the Aid flow (current US$) in Georgia in 2004 to that in 2008?
Ensure brevity in your answer.  0.23. What is the ratio of the Aid flow (current US$) of Guinea-Bissau in 2004 to that in 2008?
Keep it short and to the point. 0.16. What is the ratio of the Aid flow (current US$) in Congo (Republic) in 2004 to that in 2009?
Make the answer very short. 0.04. What is the ratio of the Aid flow (current US$) of El Salvador in 2004 to that in 2009?
Keep it short and to the point. 1.4. What is the ratio of the Aid flow (current US$) of Georgia in 2004 to that in 2009?
Your answer should be very brief. 0.33. What is the ratio of the Aid flow (current US$) of Guinea-Bissau in 2004 to that in 2009?
Your answer should be very brief. 0.1. What is the ratio of the Aid flow (current US$) in Congo (Republic) in 2005 to that in 2006?
Give a very brief answer. 1.68. What is the ratio of the Aid flow (current US$) in El Salvador in 2005 to that in 2006?
Provide a short and direct response. 1.92. What is the ratio of the Aid flow (current US$) in Georgia in 2005 to that in 2006?
Provide a short and direct response. 0.7. What is the ratio of the Aid flow (current US$) in Guinea-Bissau in 2005 to that in 2006?
Provide a short and direct response. 0.25. What is the ratio of the Aid flow (current US$) in Congo (Republic) in 2005 to that in 2007?
Provide a succinct answer. 1.57. What is the ratio of the Aid flow (current US$) of El Salvador in 2005 to that in 2007?
Your answer should be compact. 1.2. What is the ratio of the Aid flow (current US$) in Georgia in 2005 to that in 2007?
Provide a succinct answer. 0.83. What is the ratio of the Aid flow (current US$) in Guinea-Bissau in 2005 to that in 2007?
Make the answer very short. 0.22. What is the ratio of the Aid flow (current US$) in Congo (Republic) in 2005 to that in 2008?
Keep it short and to the point. 57.96. What is the ratio of the Aid flow (current US$) in El Salvador in 2005 to that in 2008?
Your answer should be compact. 1.11. What is the ratio of the Aid flow (current US$) in Georgia in 2005 to that in 2008?
Your response must be concise. 0.18. What is the ratio of the Aid flow (current US$) in Guinea-Bissau in 2005 to that in 2008?
Make the answer very short. 2.06. What is the ratio of the Aid flow (current US$) of Congo (Republic) in 2005 to that in 2009?
Your response must be concise. 1.63. What is the ratio of the Aid flow (current US$) of El Salvador in 2005 to that in 2009?
Keep it short and to the point. 0.57. What is the ratio of the Aid flow (current US$) in Georgia in 2005 to that in 2009?
Make the answer very short. 0.26. What is the ratio of the Aid flow (current US$) of Guinea-Bissau in 2005 to that in 2009?
Provide a short and direct response. 1.21. What is the ratio of the Aid flow (current US$) of Congo (Republic) in 2006 to that in 2007?
Offer a very short reply. 0.94. What is the ratio of the Aid flow (current US$) in El Salvador in 2006 to that in 2007?
Your answer should be compact. 0.63. What is the ratio of the Aid flow (current US$) of Georgia in 2006 to that in 2007?
Make the answer very short. 1.19. What is the ratio of the Aid flow (current US$) of Guinea-Bissau in 2006 to that in 2007?
Your answer should be very brief. 0.88. What is the ratio of the Aid flow (current US$) of Congo (Republic) in 2006 to that in 2008?
Provide a succinct answer. 34.54. What is the ratio of the Aid flow (current US$) of El Salvador in 2006 to that in 2008?
Provide a succinct answer. 0.58. What is the ratio of the Aid flow (current US$) of Georgia in 2006 to that in 2008?
Provide a succinct answer. 0.26. What is the ratio of the Aid flow (current US$) in Guinea-Bissau in 2006 to that in 2008?
Offer a terse response. 8.27. What is the ratio of the Aid flow (current US$) in Congo (Republic) in 2006 to that in 2009?
Give a very brief answer. 0.97. What is the ratio of the Aid flow (current US$) in El Salvador in 2006 to that in 2009?
Your answer should be compact. 0.3. What is the ratio of the Aid flow (current US$) in Georgia in 2006 to that in 2009?
Give a very brief answer. 0.37. What is the ratio of the Aid flow (current US$) of Guinea-Bissau in 2006 to that in 2009?
Your response must be concise. 4.86. What is the ratio of the Aid flow (current US$) of Congo (Republic) in 2007 to that in 2008?
Offer a terse response. 36.92. What is the ratio of the Aid flow (current US$) of El Salvador in 2007 to that in 2008?
Your response must be concise. 0.92. What is the ratio of the Aid flow (current US$) in Georgia in 2007 to that in 2008?
Your answer should be very brief. 0.22. What is the ratio of the Aid flow (current US$) in Guinea-Bissau in 2007 to that in 2008?
Keep it short and to the point. 9.4. What is the ratio of the Aid flow (current US$) in Congo (Republic) in 2007 to that in 2009?
Make the answer very short. 1.04. What is the ratio of the Aid flow (current US$) of El Salvador in 2007 to that in 2009?
Your answer should be very brief. 0.48. What is the ratio of the Aid flow (current US$) in Georgia in 2007 to that in 2009?
Offer a very short reply. 0.31. What is the ratio of the Aid flow (current US$) in Guinea-Bissau in 2007 to that in 2009?
Offer a terse response. 5.53. What is the ratio of the Aid flow (current US$) of Congo (Republic) in 2008 to that in 2009?
Your answer should be very brief. 0.03. What is the ratio of the Aid flow (current US$) of El Salvador in 2008 to that in 2009?
Offer a terse response. 0.52. What is the ratio of the Aid flow (current US$) of Georgia in 2008 to that in 2009?
Provide a short and direct response. 1.44. What is the ratio of the Aid flow (current US$) of Guinea-Bissau in 2008 to that in 2009?
Your answer should be very brief. 0.59. What is the difference between the highest and the second highest Aid flow (current US$) in Congo (Republic)?
Offer a terse response. 5.47e+06. What is the difference between the highest and the second highest Aid flow (current US$) in El Salvador?
Ensure brevity in your answer.  3.27e+07. What is the difference between the highest and the second highest Aid flow (current US$) in Georgia?
Offer a very short reply. 1.23e+08. What is the difference between the highest and the second highest Aid flow (current US$) in Guinea-Bissau?
Provide a short and direct response. 7.60e+05. What is the difference between the highest and the lowest Aid flow (current US$) in Congo (Republic)?
Offer a terse response. 1.48e+07. What is the difference between the highest and the lowest Aid flow (current US$) in El Salvador?
Ensure brevity in your answer.  9.02e+07. What is the difference between the highest and the lowest Aid flow (current US$) in Georgia?
Ensure brevity in your answer.  3.30e+08. What is the difference between the highest and the lowest Aid flow (current US$) of Guinea-Bissau?
Offer a very short reply. 6.19e+06. 